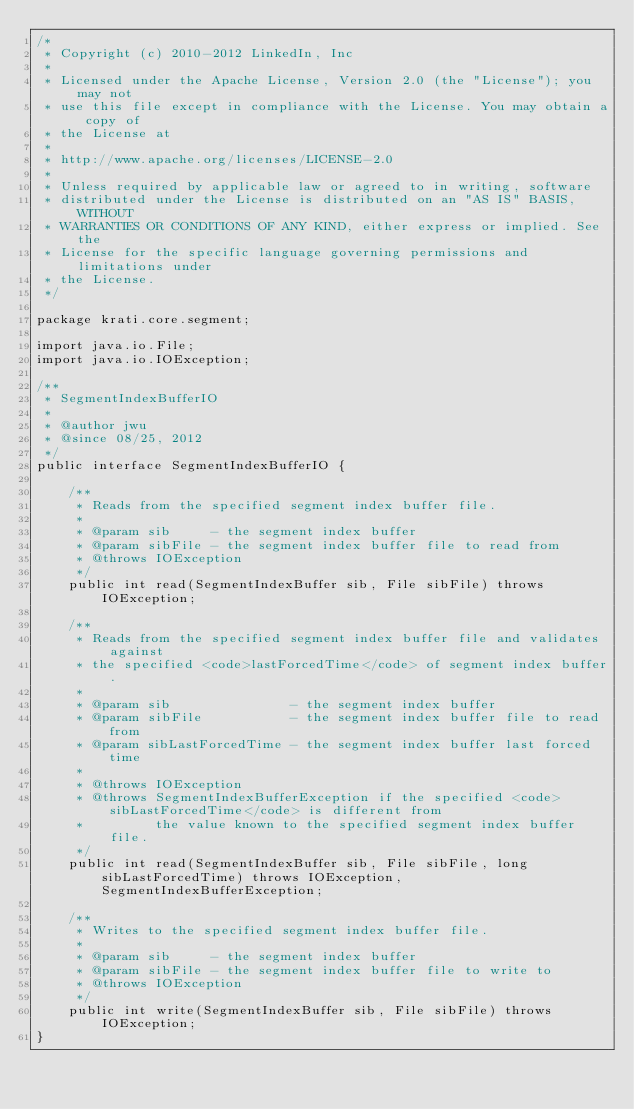Convert code to text. <code><loc_0><loc_0><loc_500><loc_500><_Java_>/*
 * Copyright (c) 2010-2012 LinkedIn, Inc
 * 
 * Licensed under the Apache License, Version 2.0 (the "License"); you may not
 * use this file except in compliance with the License. You may obtain a copy of
 * the License at
 * 
 * http://www.apache.org/licenses/LICENSE-2.0
 * 
 * Unless required by applicable law or agreed to in writing, software
 * distributed under the License is distributed on an "AS IS" BASIS, WITHOUT
 * WARRANTIES OR CONDITIONS OF ANY KIND, either express or implied. See the
 * License for the specific language governing permissions and limitations under
 * the License.
 */

package krati.core.segment;

import java.io.File;
import java.io.IOException;

/**
 * SegmentIndexBufferIO
 * 
 * @author jwu
 * @since 08/25, 2012
 */
public interface SegmentIndexBufferIO {
    
    /**
     * Reads from the specified segment index buffer file.
     *  
     * @param sib     - the segment index buffer
     * @param sibFile - the segment index buffer file to read from
     * @throws IOException
     */
    public int read(SegmentIndexBuffer sib, File sibFile) throws IOException;
    
    /**
     * Reads from the specified segment index buffer file and validates against
     * the specified <code>lastForcedTime</code> of segment index buffer.
     *  
     * @param sib               - the segment index buffer
     * @param sibFile           - the segment index buffer file to read from
     * @param sibLastForcedTime - the segment index buffer last forced time
     * 
     * @throws IOException
     * @throws SegmentIndexBufferException if the specified <code>sibLastForcedTime</code> is different from
     *         the value known to the specified segment index buffer file.
     */
    public int read(SegmentIndexBuffer sib, File sibFile, long sibLastForcedTime) throws IOException, SegmentIndexBufferException;
    
    /**
     * Writes to the specified segment index buffer file.
     * 
     * @param sib     - the segment index buffer
     * @param sibFile - the segment index buffer file to write to
     * @throws IOException
     */
    public int write(SegmentIndexBuffer sib, File sibFile) throws IOException;
}
</code> 